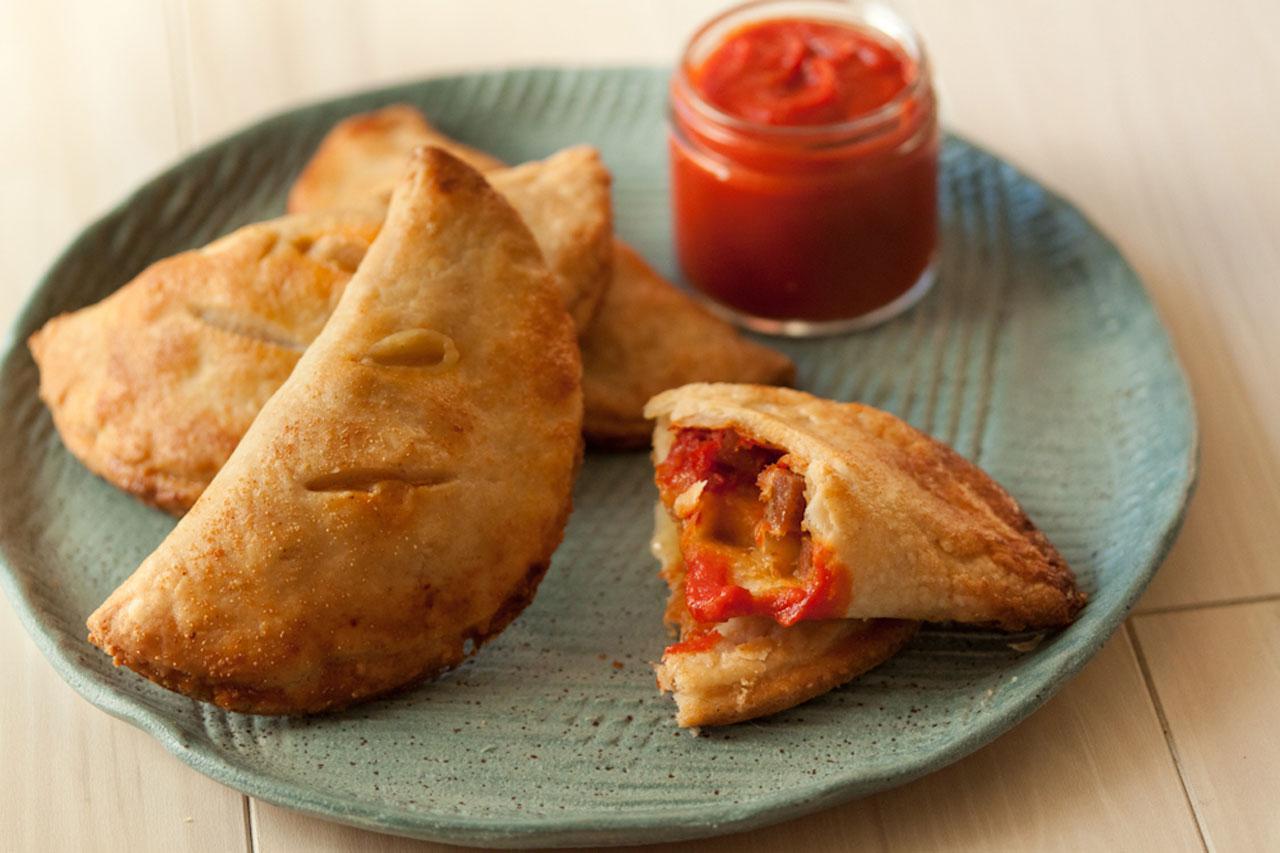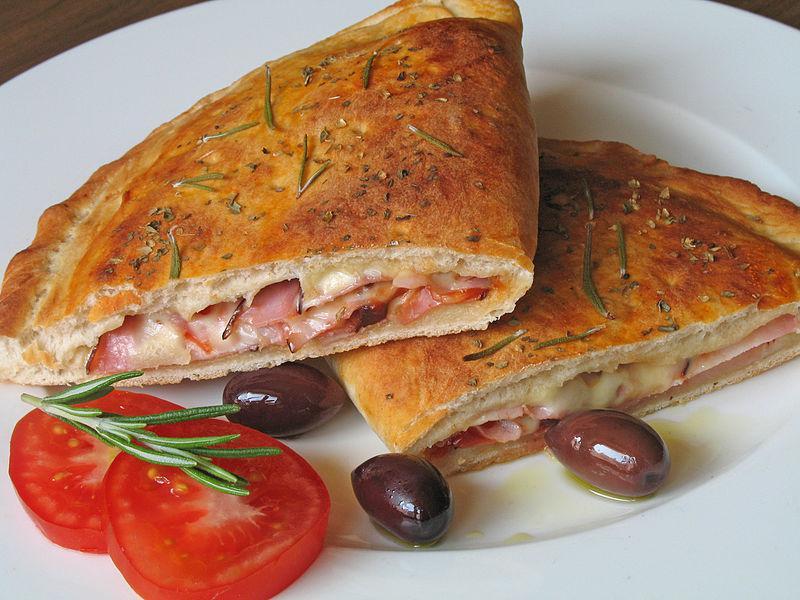The first image is the image on the left, the second image is the image on the right. Assess this claim about the two images: "In the left image the food is on a white plate.". Correct or not? Answer yes or no. No. The first image is the image on the left, the second image is the image on the right. Evaluate the accuracy of this statement regarding the images: "The left image shows calzones on a non-white plate.". Is it true? Answer yes or no. Yes. 